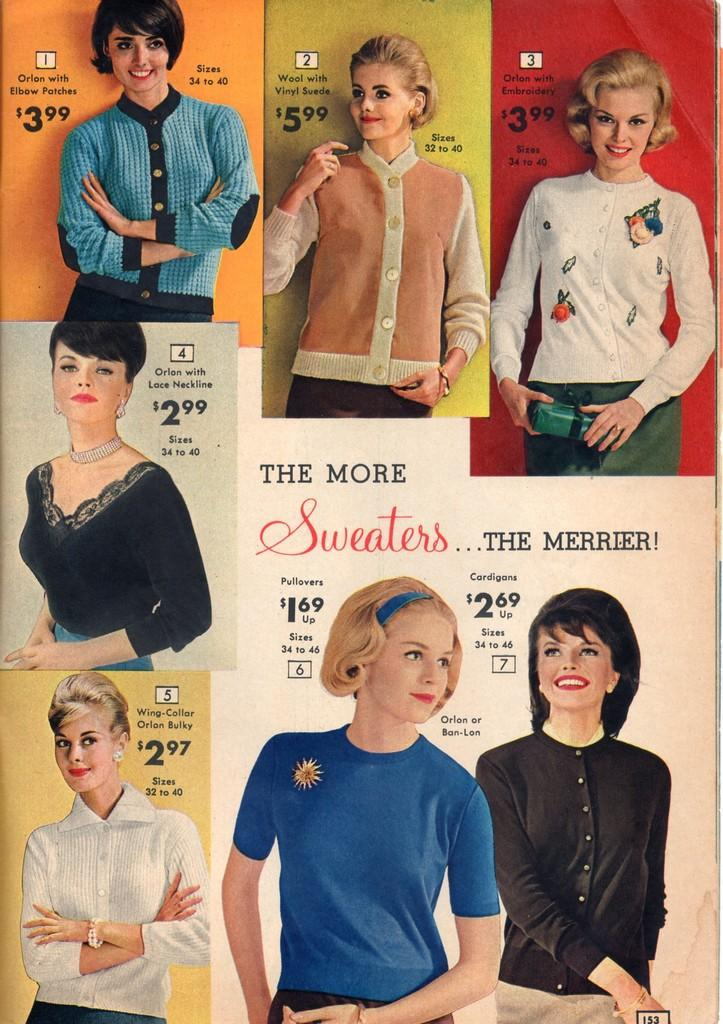What type of artwork is shown in the image? The image is a collage. What is the main subject of the collage? The collage consists of various images of women. How are the women depicted in the collage? The women are depicted in different costumes. What additional elements are present in each image of the collage? Each image contains text and dollars. What type of bead is used to create the text in the image? There is no bead present in the image; the text is not created using beads. Can you identify the type of wrench used by the women in the image? There are no wrenches present in the image; the women are depicted in different costumes, but none of them involve wrenches. 